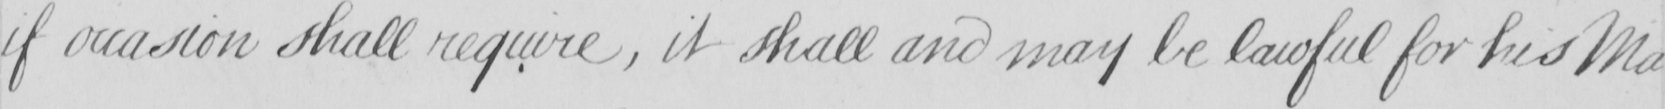What text is written in this handwritten line? if occasion shall require , it shall and may be lawful for his Ma- 